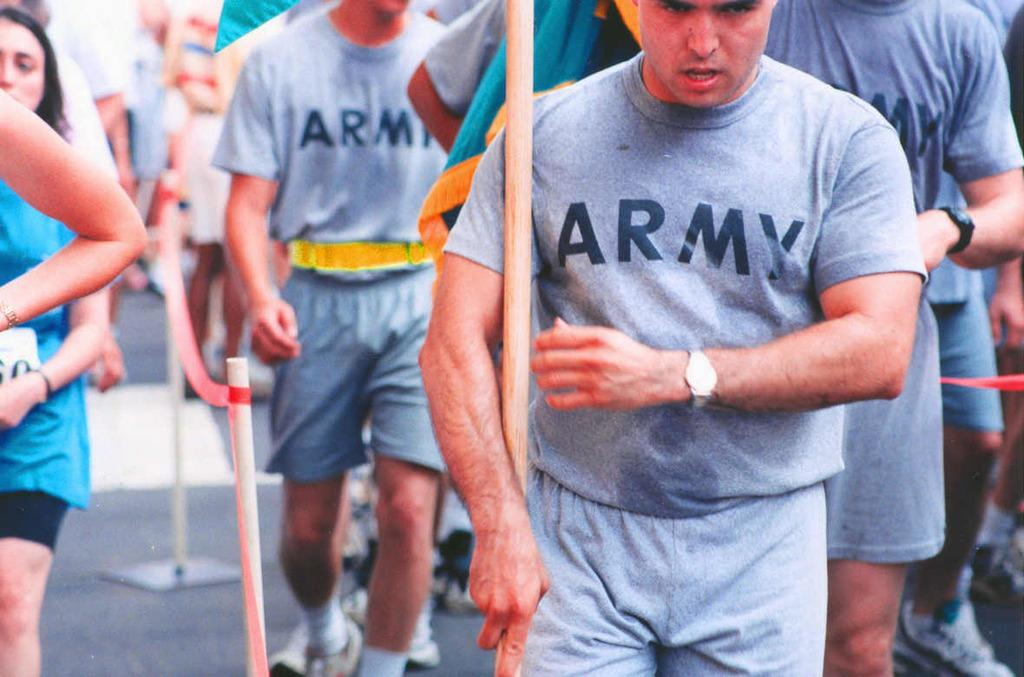Provide a one-sentence caption for the provided image. a man that is wearing an army shirt. 